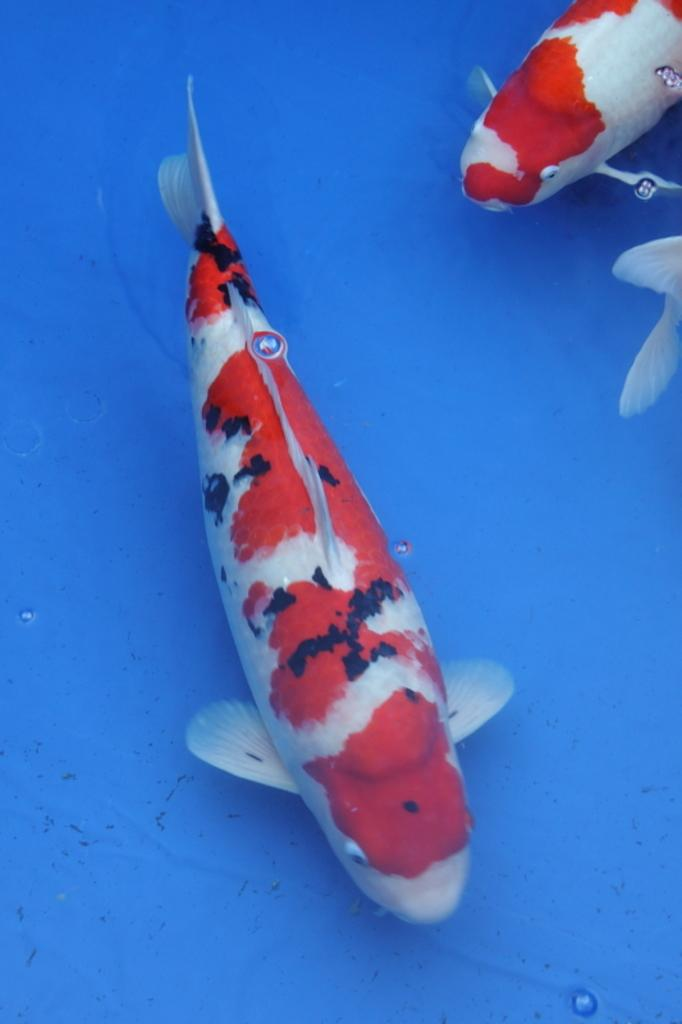How many fishes can be seen in the image? There are two fishes in the image. What is the color combination of the fishes? The fishes have a red and white color combination. What are the fishes doing in the image? The fishes are swimming in the water. What color is the background of the image? The background of the image is blue in color. What type of prison can be seen in the background of the image? There is no prison present in the image; the background is blue in color. What idea does the image represent? The image does not represent an idea; it is a visual representation of two fishes swimming in the water with a blue background. 